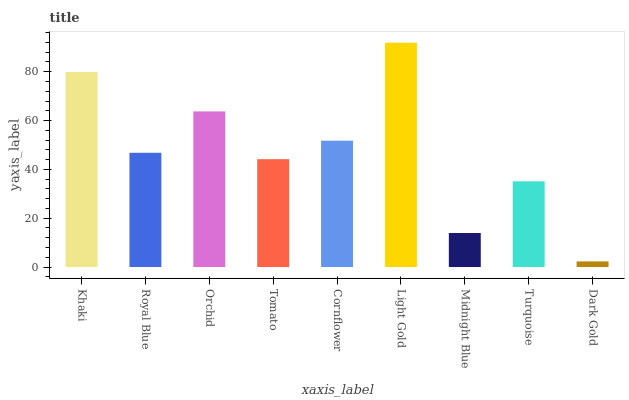Is Dark Gold the minimum?
Answer yes or no. Yes. Is Light Gold the maximum?
Answer yes or no. Yes. Is Royal Blue the minimum?
Answer yes or no. No. Is Royal Blue the maximum?
Answer yes or no. No. Is Khaki greater than Royal Blue?
Answer yes or no. Yes. Is Royal Blue less than Khaki?
Answer yes or no. Yes. Is Royal Blue greater than Khaki?
Answer yes or no. No. Is Khaki less than Royal Blue?
Answer yes or no. No. Is Royal Blue the high median?
Answer yes or no. Yes. Is Royal Blue the low median?
Answer yes or no. Yes. Is Cornflower the high median?
Answer yes or no. No. Is Khaki the low median?
Answer yes or no. No. 